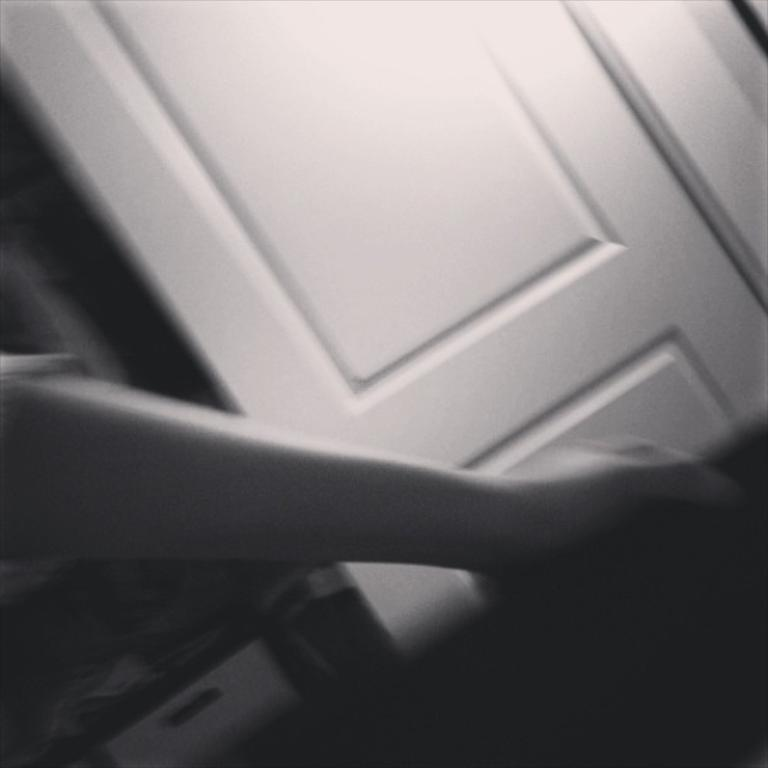What type of door is visible in the image? There is a white door in the image. What is the person in the image doing? The person is holding an object in the image. What can be seen on the surface in the image? There are different objects on a surface in the image. What type of pipe can be seen in the image? There is no pipe present in the image. Is the person playing a guitar in the image? There is no guitar present in the image. 